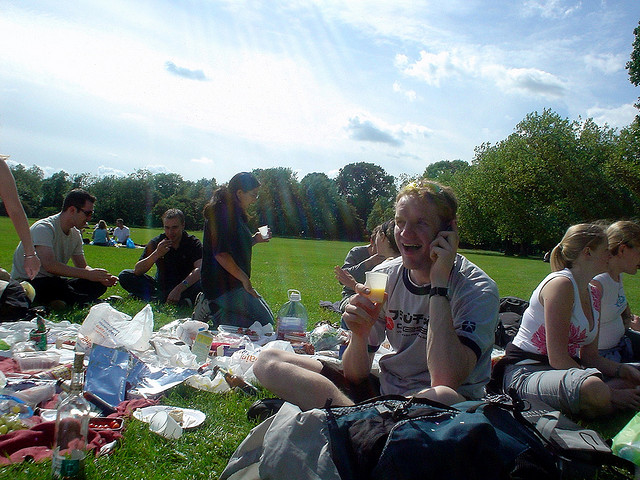<image>What color is the hat on the man in the foreground? There is no hat on the man in the foreground. What color is the hat on the man in the foreground? It is unknown what color the hat on the man in the foreground is. There is no hat in the image. 